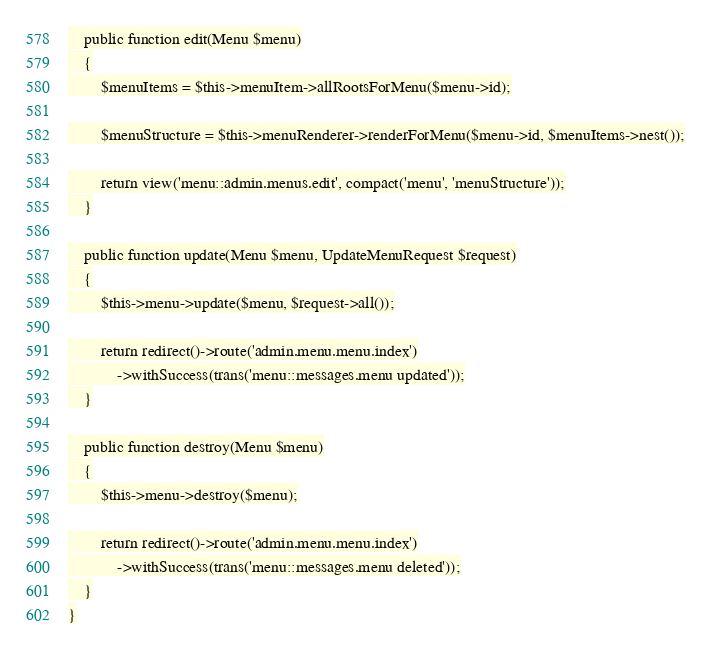Convert code to text. <code><loc_0><loc_0><loc_500><loc_500><_PHP_>    public function edit(Menu $menu)
    {
        $menuItems = $this->menuItem->allRootsForMenu($menu->id);

        $menuStructure = $this->menuRenderer->renderForMenu($menu->id, $menuItems->nest());

        return view('menu::admin.menus.edit', compact('menu', 'menuStructure'));
    }

    public function update(Menu $menu, UpdateMenuRequest $request)
    {
        $this->menu->update($menu, $request->all());

        return redirect()->route('admin.menu.menu.index')
            ->withSuccess(trans('menu::messages.menu updated'));
    }

    public function destroy(Menu $menu)
    {
        $this->menu->destroy($menu);

        return redirect()->route('admin.menu.menu.index')
            ->withSuccess(trans('menu::messages.menu deleted'));
    }
}
</code> 